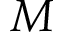Convert formula to latex. <formula><loc_0><loc_0><loc_500><loc_500>M</formula> 